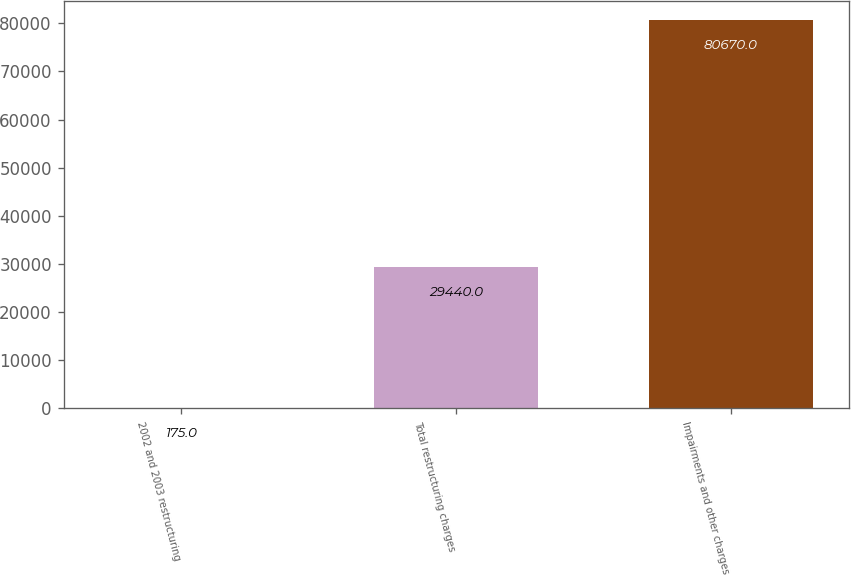Convert chart to OTSL. <chart><loc_0><loc_0><loc_500><loc_500><bar_chart><fcel>2002 and 2003 restructuring<fcel>Total restructuring charges<fcel>Impairments and other charges<nl><fcel>175<fcel>29440<fcel>80670<nl></chart> 